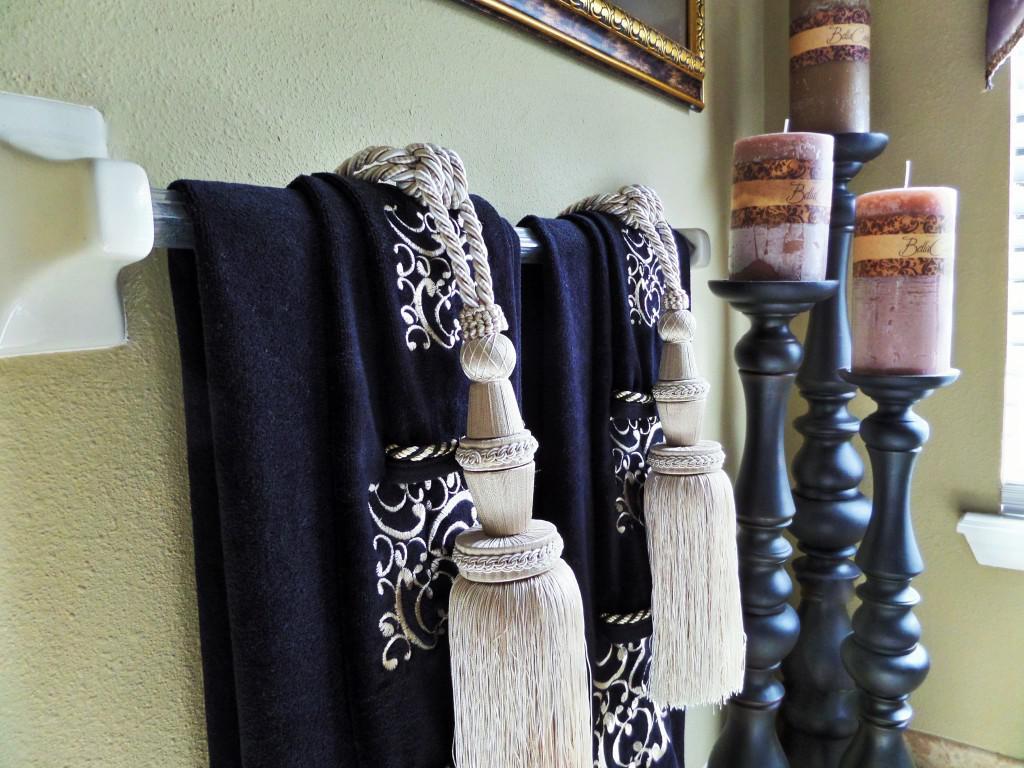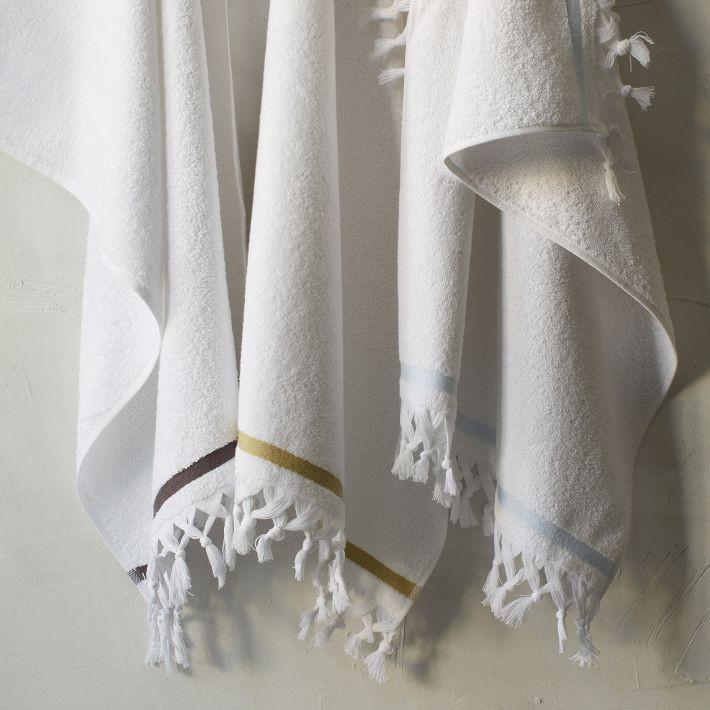The first image is the image on the left, the second image is the image on the right. Analyze the images presented: Is the assertion "An equal number of towels is hanging in each image." valid? Answer yes or no. No. 